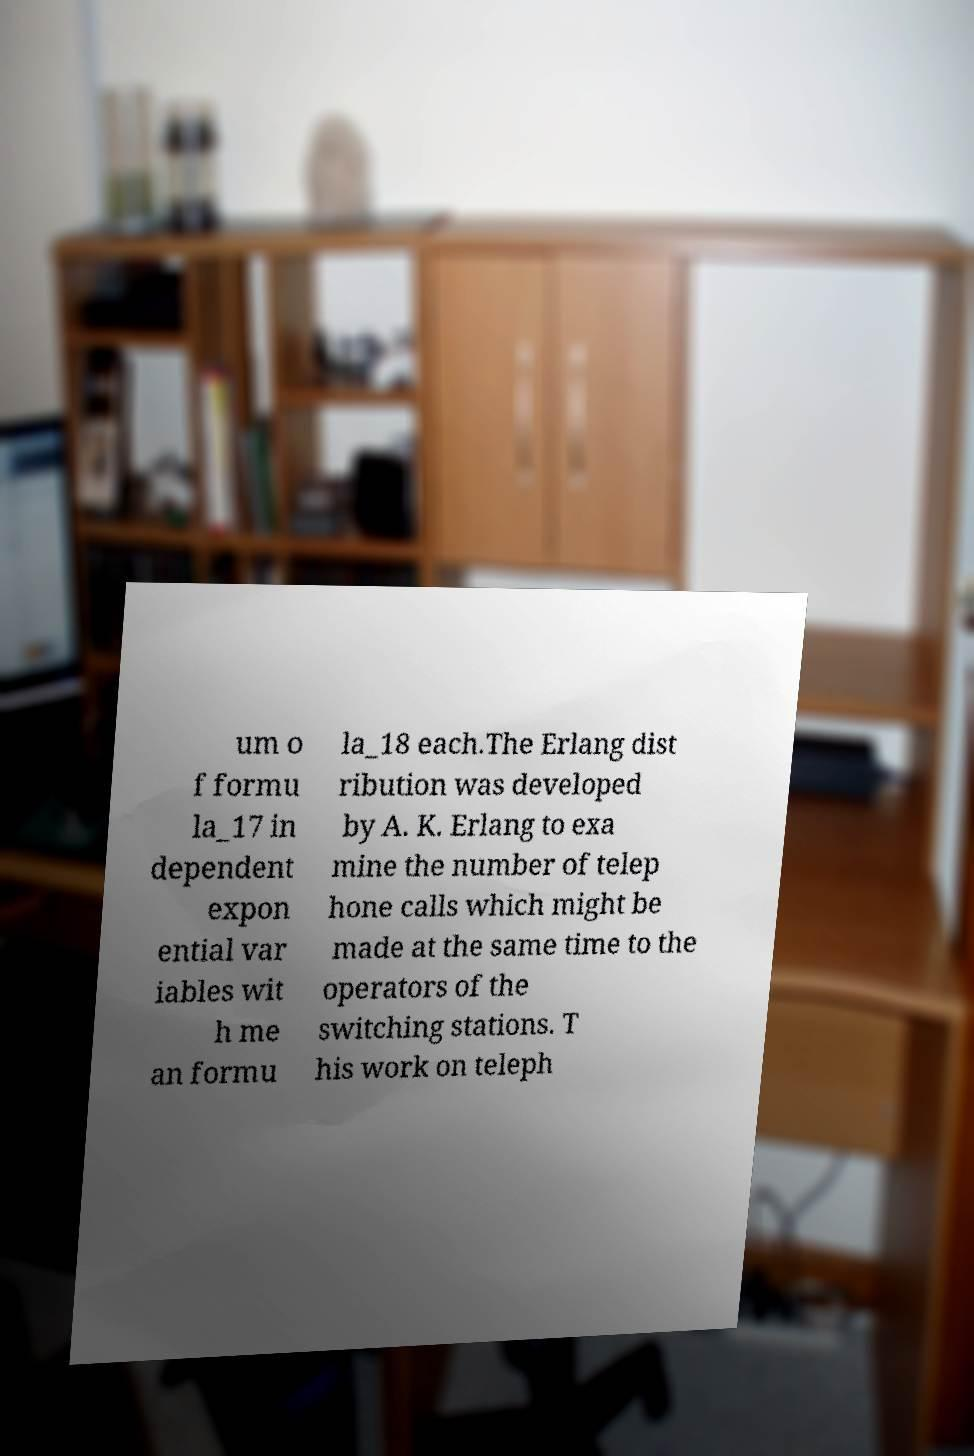Please read and relay the text visible in this image. What does it say? um o f formu la_17 in dependent expon ential var iables wit h me an formu la_18 each.The Erlang dist ribution was developed by A. K. Erlang to exa mine the number of telep hone calls which might be made at the same time to the operators of the switching stations. T his work on teleph 